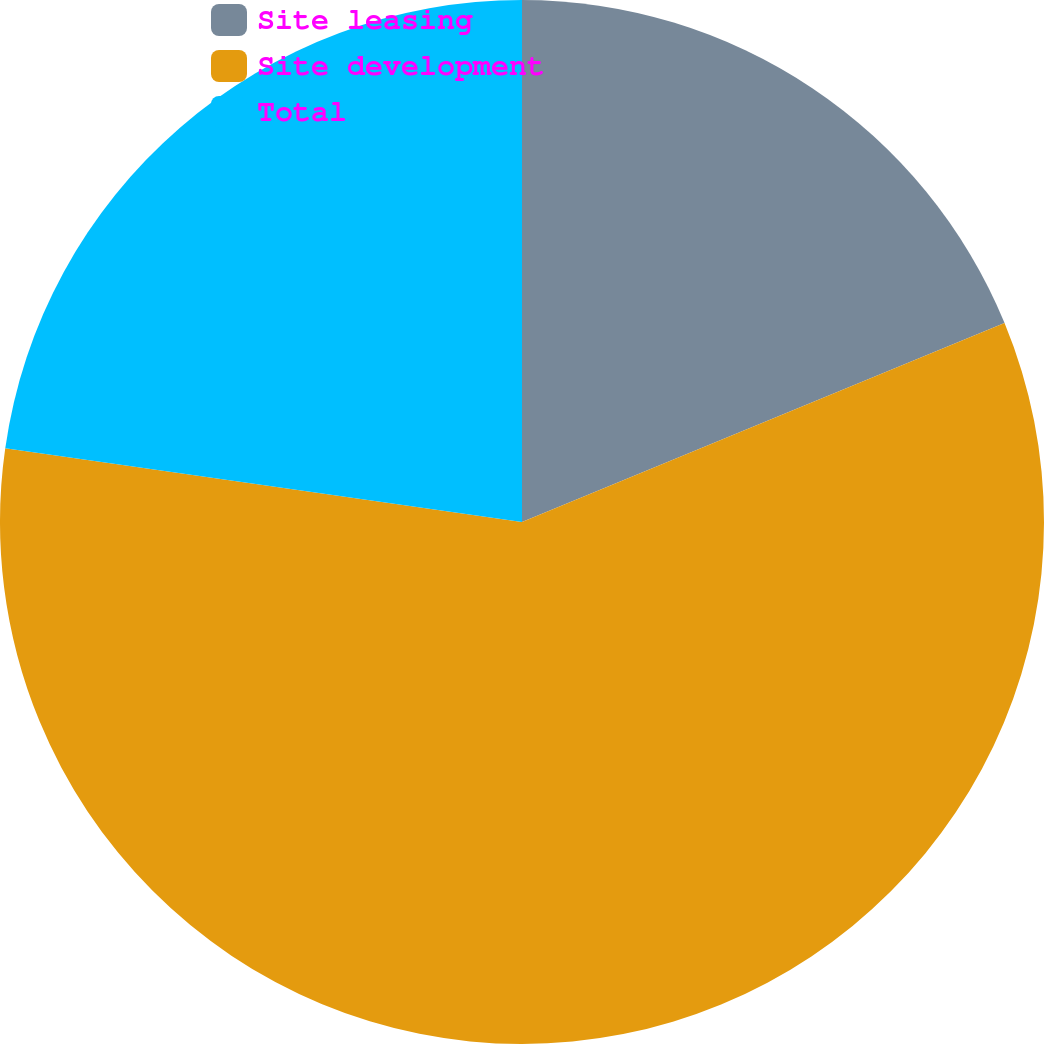<chart> <loc_0><loc_0><loc_500><loc_500><pie_chart><fcel>Site leasing<fcel>Site development<fcel>Total<nl><fcel>18.77%<fcel>58.48%<fcel>22.74%<nl></chart> 